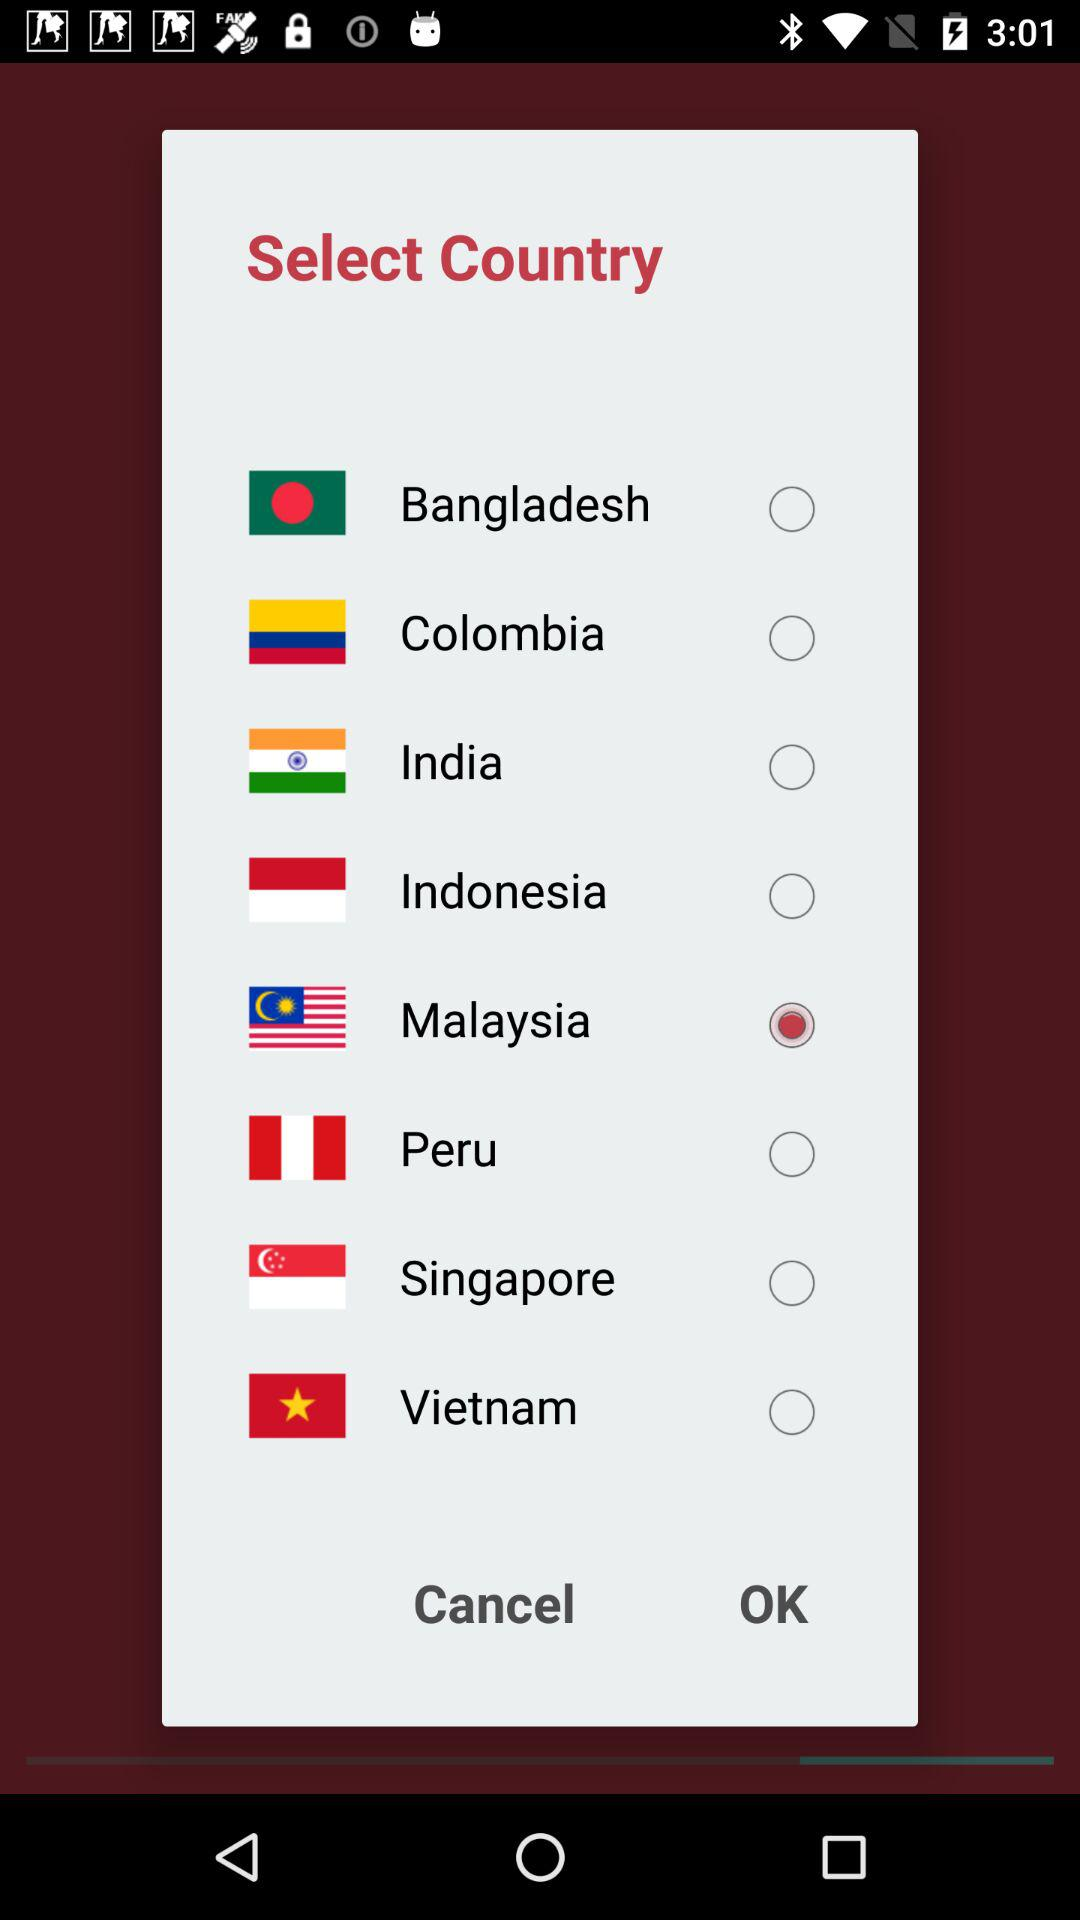How many countries are available to select from?
Answer the question using a single word or phrase. 8 